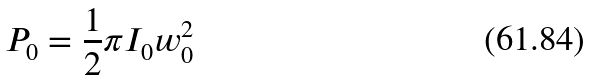<formula> <loc_0><loc_0><loc_500><loc_500>P _ { 0 } = \frac { 1 } { 2 } \pi I _ { 0 } w _ { 0 } ^ { 2 }</formula> 